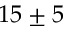Convert formula to latex. <formula><loc_0><loc_0><loc_500><loc_500>1 5 \pm 5</formula> 